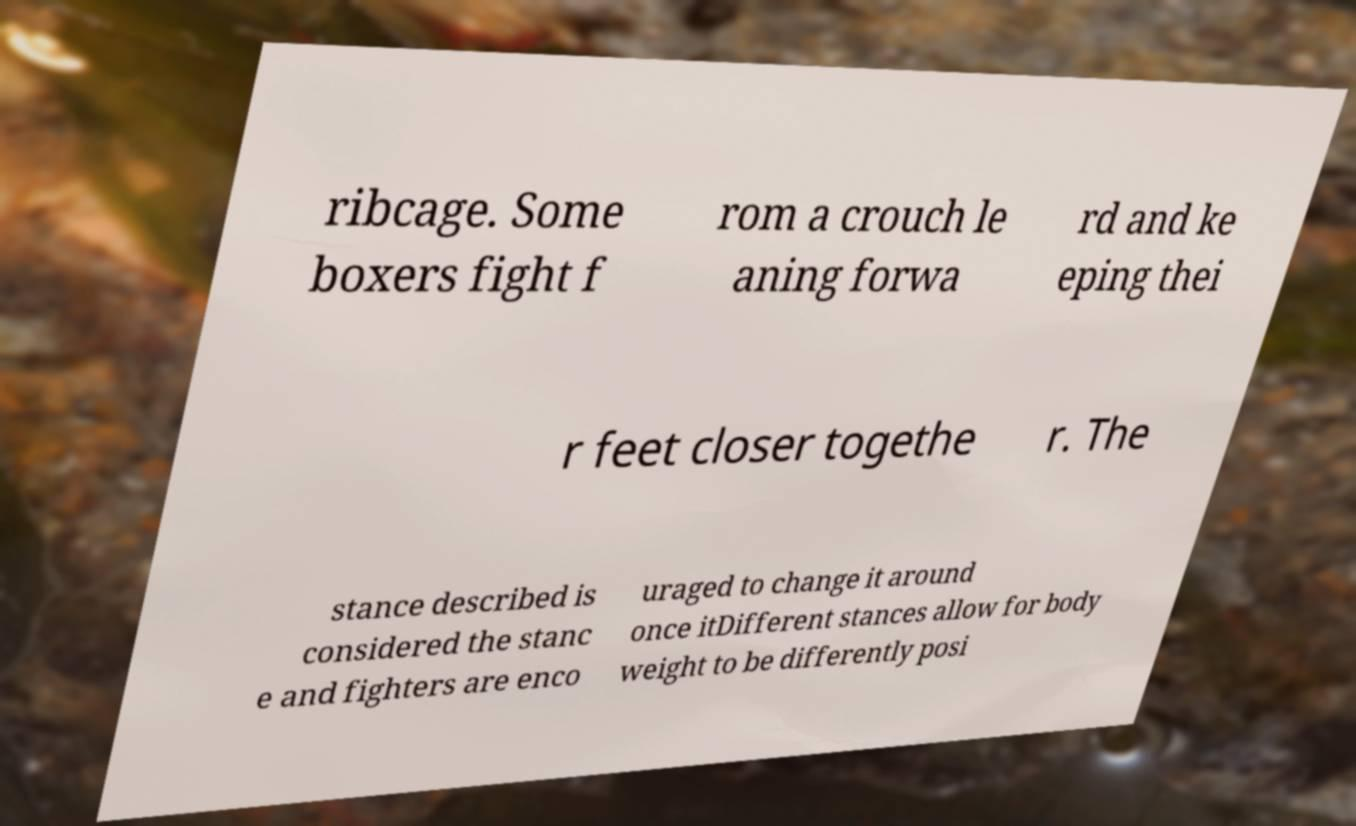I need the written content from this picture converted into text. Can you do that? ribcage. Some boxers fight f rom a crouch le aning forwa rd and ke eping thei r feet closer togethe r. The stance described is considered the stanc e and fighters are enco uraged to change it around once itDifferent stances allow for body weight to be differently posi 